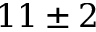Convert formula to latex. <formula><loc_0><loc_0><loc_500><loc_500>1 1 \pm 2</formula> 